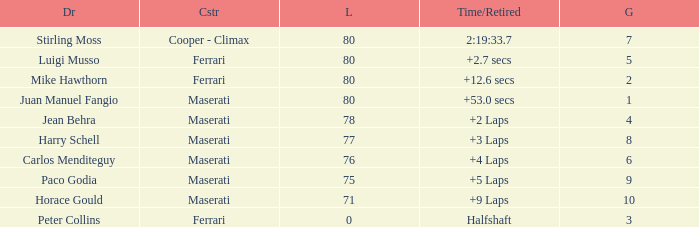What's the average Grid for a Maserati with less than 80 laps, and a Time/Retired of +2 laps? 4.0. 